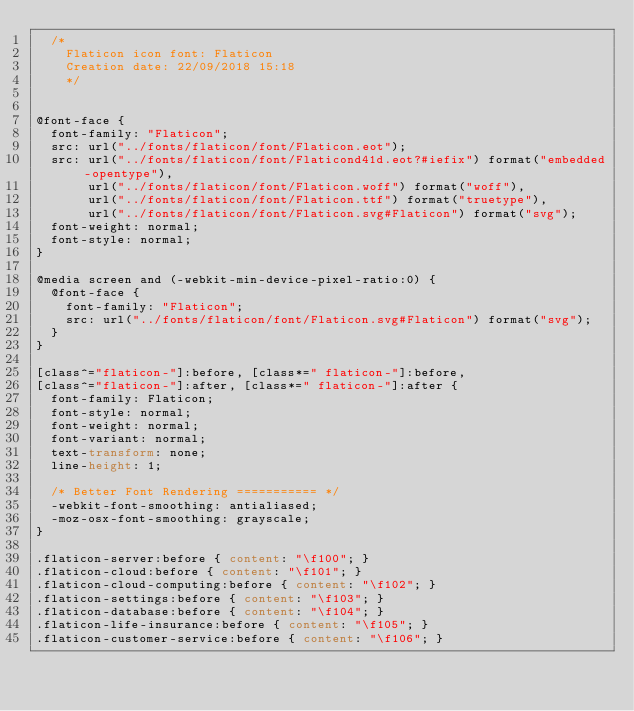Convert code to text. <code><loc_0><loc_0><loc_500><loc_500><_CSS_>	/*
  	Flaticon icon font: Flaticon
  	Creation date: 22/09/2018 15:18
  	*/


@font-face {
  font-family: "Flaticon";
  src: url("../fonts/flaticon/font/Flaticon.eot");
  src: url("../fonts/flaticon/font/Flaticond41d.eot?#iefix") format("embedded-opentype"),
       url("../fonts/flaticon/font/Flaticon.woff") format("woff"),
       url("../fonts/flaticon/font/Flaticon.ttf") format("truetype"),
       url("../fonts/flaticon/font/Flaticon.svg#Flaticon") format("svg");
  font-weight: normal;
  font-style: normal;
}

@media screen and (-webkit-min-device-pixel-ratio:0) {
  @font-face {
    font-family: "Flaticon";
    src: url("../fonts/flaticon/font/Flaticon.svg#Flaticon") format("svg");
  }
}

[class^="flaticon-"]:before, [class*=" flaticon-"]:before,
[class^="flaticon-"]:after, [class*=" flaticon-"]:after {   
  font-family: Flaticon;
  font-style: normal;
  font-weight: normal;
  font-variant: normal;
  text-transform: none;
  line-height: 1;

  /* Better Font Rendering =========== */
  -webkit-font-smoothing: antialiased;
  -moz-osx-font-smoothing: grayscale;
}

.flaticon-server:before { content: "\f100"; }
.flaticon-cloud:before { content: "\f101"; }
.flaticon-cloud-computing:before { content: "\f102"; }
.flaticon-settings:before { content: "\f103"; }
.flaticon-database:before { content: "\f104"; }
.flaticon-life-insurance:before { content: "\f105"; }
.flaticon-customer-service:before { content: "\f106"; }</code> 